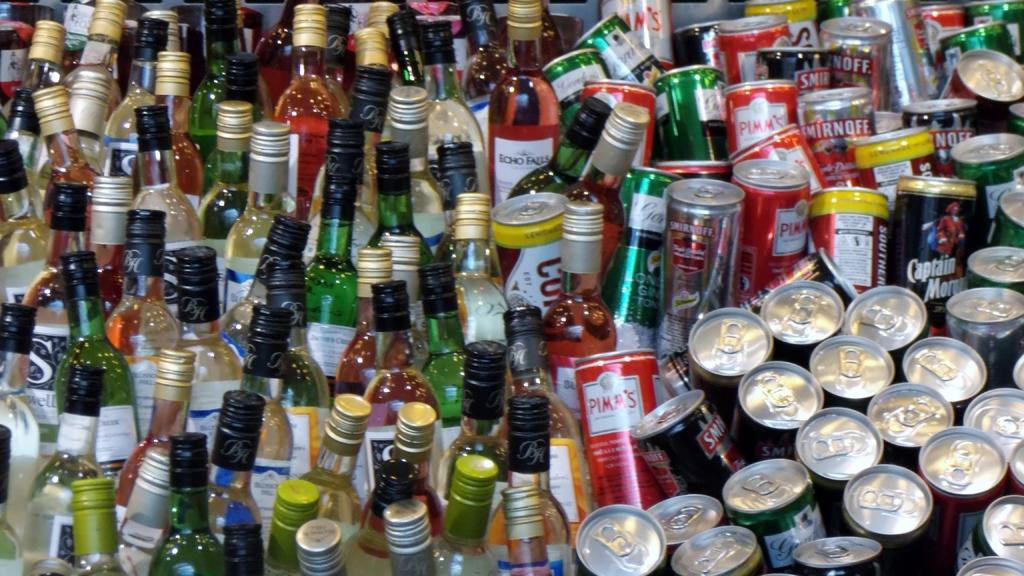What types of containers are visible in the image? There are tins and bottles in the image. What type of education can be seen in the image? There is no reference to education in the image; it only features tins and bottles. 